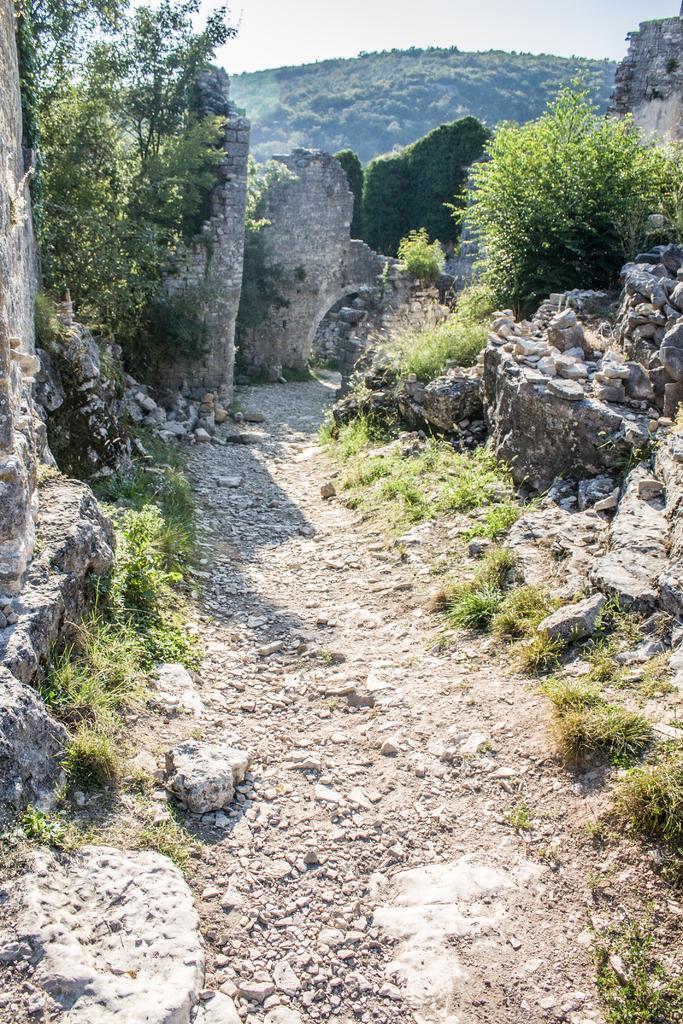Describe this image in one or two sentences. In the center of the picture there are stones and it is the path. On the left there are shrubs, trees and walls. On the right there are stones, shrubs, tree and wall. In the background there is a hill covered with trees. 